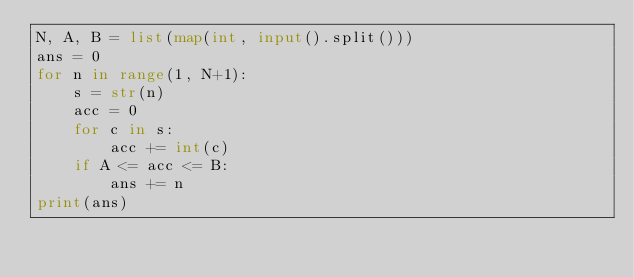Convert code to text. <code><loc_0><loc_0><loc_500><loc_500><_Python_>N, A, B = list(map(int, input().split()))
ans = 0
for n in range(1, N+1):
    s = str(n)
    acc = 0
    for c in s:
        acc += int(c)
    if A <= acc <= B:
        ans += n
print(ans)
</code> 